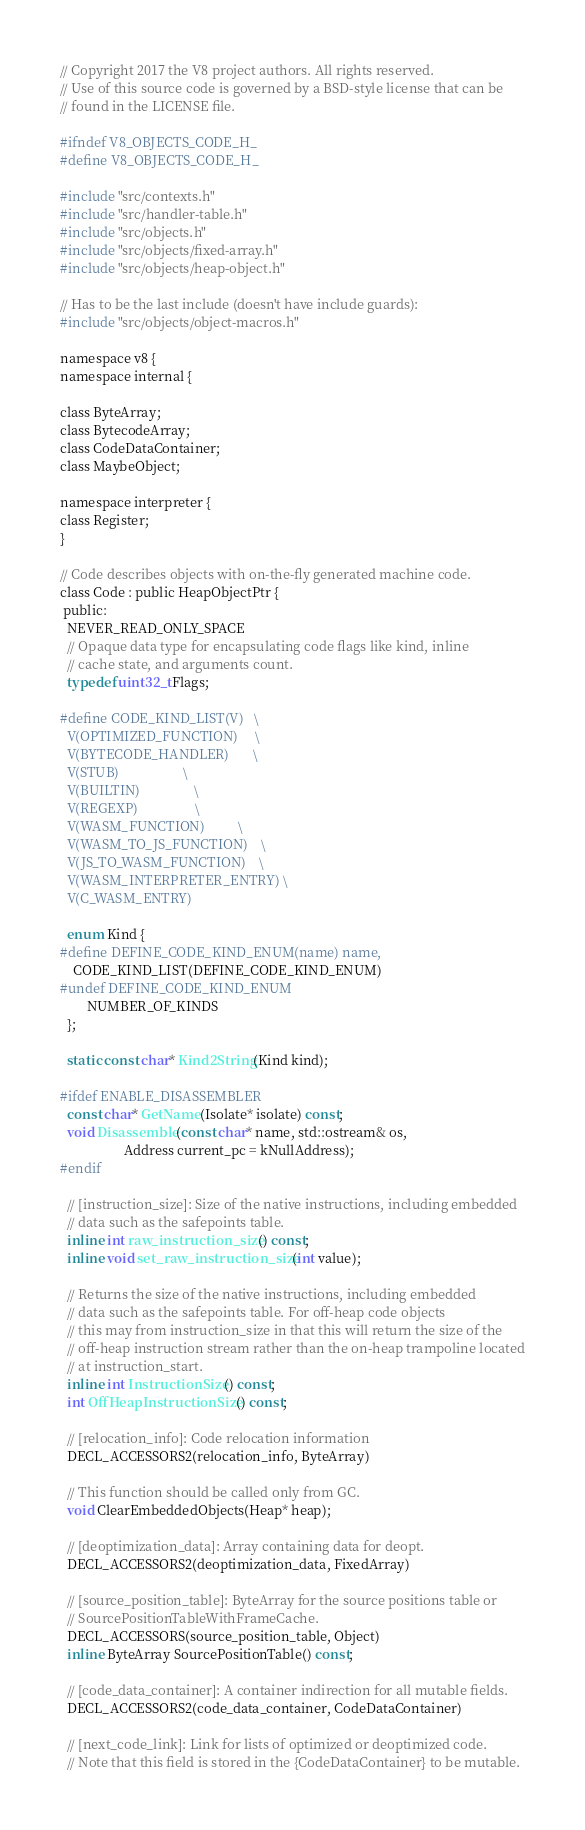Convert code to text. <code><loc_0><loc_0><loc_500><loc_500><_C_>// Copyright 2017 the V8 project authors. All rights reserved.
// Use of this source code is governed by a BSD-style license that can be
// found in the LICENSE file.

#ifndef V8_OBJECTS_CODE_H_
#define V8_OBJECTS_CODE_H_

#include "src/contexts.h"
#include "src/handler-table.h"
#include "src/objects.h"
#include "src/objects/fixed-array.h"
#include "src/objects/heap-object.h"

// Has to be the last include (doesn't have include guards):
#include "src/objects/object-macros.h"

namespace v8 {
namespace internal {

class ByteArray;
class BytecodeArray;
class CodeDataContainer;
class MaybeObject;

namespace interpreter {
class Register;
}

// Code describes objects with on-the-fly generated machine code.
class Code : public HeapObjectPtr {
 public:
  NEVER_READ_ONLY_SPACE
  // Opaque data type for encapsulating code flags like kind, inline
  // cache state, and arguments count.
  typedef uint32_t Flags;

#define CODE_KIND_LIST(V)   \
  V(OPTIMIZED_FUNCTION)     \
  V(BYTECODE_HANDLER)       \
  V(STUB)                   \
  V(BUILTIN)                \
  V(REGEXP)                 \
  V(WASM_FUNCTION)          \
  V(WASM_TO_JS_FUNCTION)    \
  V(JS_TO_WASM_FUNCTION)    \
  V(WASM_INTERPRETER_ENTRY) \
  V(C_WASM_ENTRY)

  enum Kind {
#define DEFINE_CODE_KIND_ENUM(name) name,
    CODE_KIND_LIST(DEFINE_CODE_KIND_ENUM)
#undef DEFINE_CODE_KIND_ENUM
        NUMBER_OF_KINDS
  };

  static const char* Kind2String(Kind kind);

#ifdef ENABLE_DISASSEMBLER
  const char* GetName(Isolate* isolate) const;
  void Disassemble(const char* name, std::ostream& os,
                   Address current_pc = kNullAddress);
#endif

  // [instruction_size]: Size of the native instructions, including embedded
  // data such as the safepoints table.
  inline int raw_instruction_size() const;
  inline void set_raw_instruction_size(int value);

  // Returns the size of the native instructions, including embedded
  // data such as the safepoints table. For off-heap code objects
  // this may from instruction_size in that this will return the size of the
  // off-heap instruction stream rather than the on-heap trampoline located
  // at instruction_start.
  inline int InstructionSize() const;
  int OffHeapInstructionSize() const;

  // [relocation_info]: Code relocation information
  DECL_ACCESSORS2(relocation_info, ByteArray)

  // This function should be called only from GC.
  void ClearEmbeddedObjects(Heap* heap);

  // [deoptimization_data]: Array containing data for deopt.
  DECL_ACCESSORS2(deoptimization_data, FixedArray)

  // [source_position_table]: ByteArray for the source positions table or
  // SourcePositionTableWithFrameCache.
  DECL_ACCESSORS(source_position_table, Object)
  inline ByteArray SourcePositionTable() const;

  // [code_data_container]: A container indirection for all mutable fields.
  DECL_ACCESSORS2(code_data_container, CodeDataContainer)

  // [next_code_link]: Link for lists of optimized or deoptimized code.
  // Note that this field is stored in the {CodeDataContainer} to be mutable.</code> 